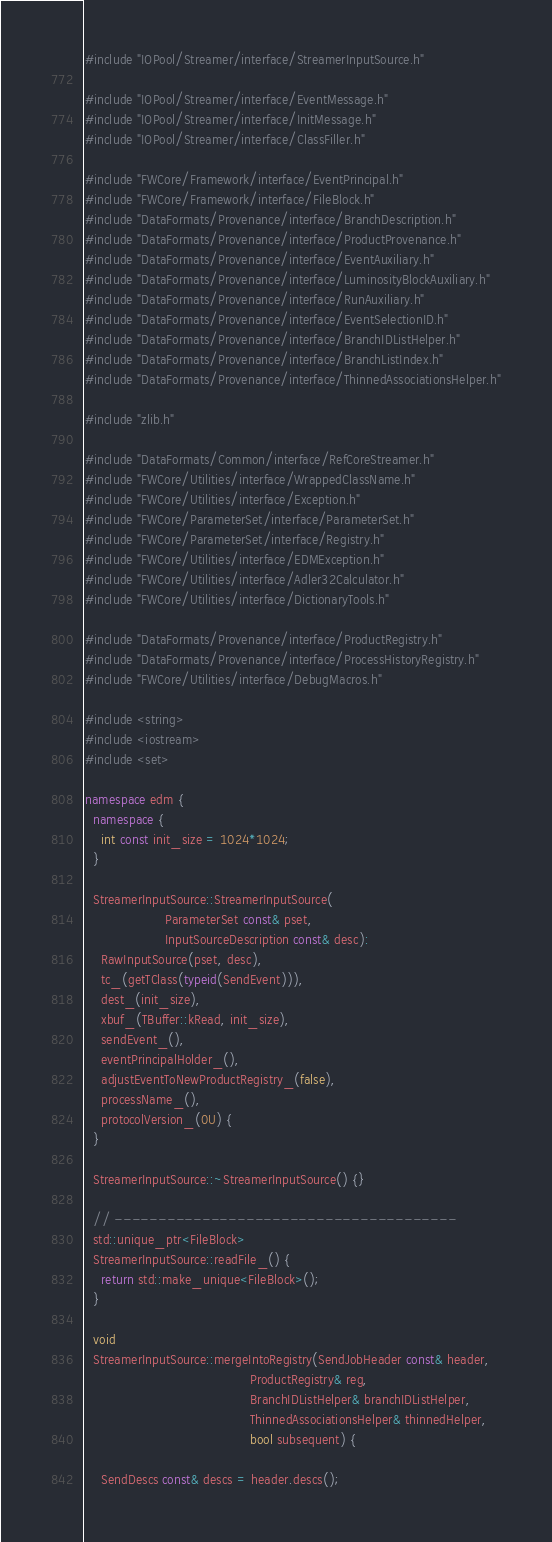<code> <loc_0><loc_0><loc_500><loc_500><_C++_>#include "IOPool/Streamer/interface/StreamerInputSource.h"

#include "IOPool/Streamer/interface/EventMessage.h"
#include "IOPool/Streamer/interface/InitMessage.h"
#include "IOPool/Streamer/interface/ClassFiller.h"

#include "FWCore/Framework/interface/EventPrincipal.h"
#include "FWCore/Framework/interface/FileBlock.h"
#include "DataFormats/Provenance/interface/BranchDescription.h"
#include "DataFormats/Provenance/interface/ProductProvenance.h"
#include "DataFormats/Provenance/interface/EventAuxiliary.h"
#include "DataFormats/Provenance/interface/LuminosityBlockAuxiliary.h"
#include "DataFormats/Provenance/interface/RunAuxiliary.h"
#include "DataFormats/Provenance/interface/EventSelectionID.h"
#include "DataFormats/Provenance/interface/BranchIDListHelper.h"
#include "DataFormats/Provenance/interface/BranchListIndex.h"
#include "DataFormats/Provenance/interface/ThinnedAssociationsHelper.h"

#include "zlib.h"

#include "DataFormats/Common/interface/RefCoreStreamer.h"
#include "FWCore/Utilities/interface/WrappedClassName.h"
#include "FWCore/Utilities/interface/Exception.h"
#include "FWCore/ParameterSet/interface/ParameterSet.h"
#include "FWCore/ParameterSet/interface/Registry.h"
#include "FWCore/Utilities/interface/EDMException.h"
#include "FWCore/Utilities/interface/Adler32Calculator.h"
#include "FWCore/Utilities/interface/DictionaryTools.h"

#include "DataFormats/Provenance/interface/ProductRegistry.h"
#include "DataFormats/Provenance/interface/ProcessHistoryRegistry.h"
#include "FWCore/Utilities/interface/DebugMacros.h"

#include <string>
#include <iostream>
#include <set>

namespace edm {
  namespace {
    int const init_size = 1024*1024;
  }

  StreamerInputSource::StreamerInputSource(
                    ParameterSet const& pset,
                    InputSourceDescription const& desc):
    RawInputSource(pset, desc),
    tc_(getTClass(typeid(SendEvent))),
    dest_(init_size),
    xbuf_(TBuffer::kRead, init_size),
    sendEvent_(),
    eventPrincipalHolder_(),
    adjustEventToNewProductRegistry_(false),
    processName_(),
    protocolVersion_(0U) {
  }

  StreamerInputSource::~StreamerInputSource() {}

  // ---------------------------------------
  std::unique_ptr<FileBlock>
  StreamerInputSource::readFile_() {
    return std::make_unique<FileBlock>();
  }

  void
  StreamerInputSource::mergeIntoRegistry(SendJobHeader const& header,
                                         ProductRegistry& reg,
                                         BranchIDListHelper& branchIDListHelper,
                                         ThinnedAssociationsHelper& thinnedHelper,
                                         bool subsequent) {

    SendDescs const& descs = header.descs();
</code> 